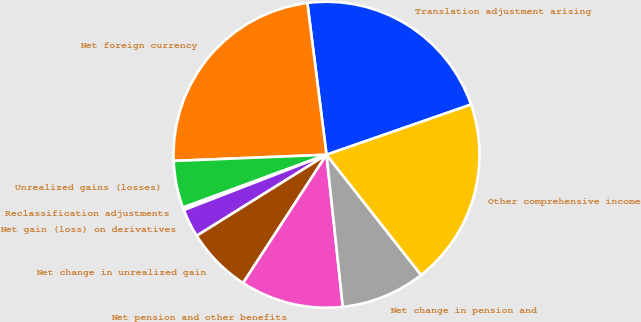Convert chart. <chart><loc_0><loc_0><loc_500><loc_500><pie_chart><fcel>Translation adjustment arising<fcel>Net foreign currency<fcel>Unrealized gains (losses)<fcel>Reclassification adjustments<fcel>Net gain (loss) on derivatives<fcel>Net change in unrealized gain<fcel>Net pension and other benefits<fcel>Net change in pension and<fcel>Other comprehensive income<nl><fcel>21.68%<fcel>23.65%<fcel>4.97%<fcel>0.27%<fcel>3.0%<fcel>6.94%<fcel>10.88%<fcel>8.91%<fcel>19.71%<nl></chart> 